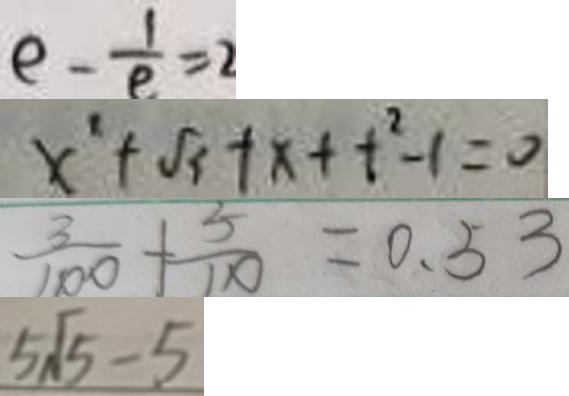Convert formula to latex. <formula><loc_0><loc_0><loc_500><loc_500>e - \frac { 1 } { e } = 2 
 x ^ { \prime } + \sqrt { 3 } + x + t ^ { 2 } - 1 = 0 
 \frac { 3 } { 1 0 0 } + \frac { 5 } { 1 1 0 } = 0 . 5 3 
 5 \sqrt { 5 } - 5</formula> 